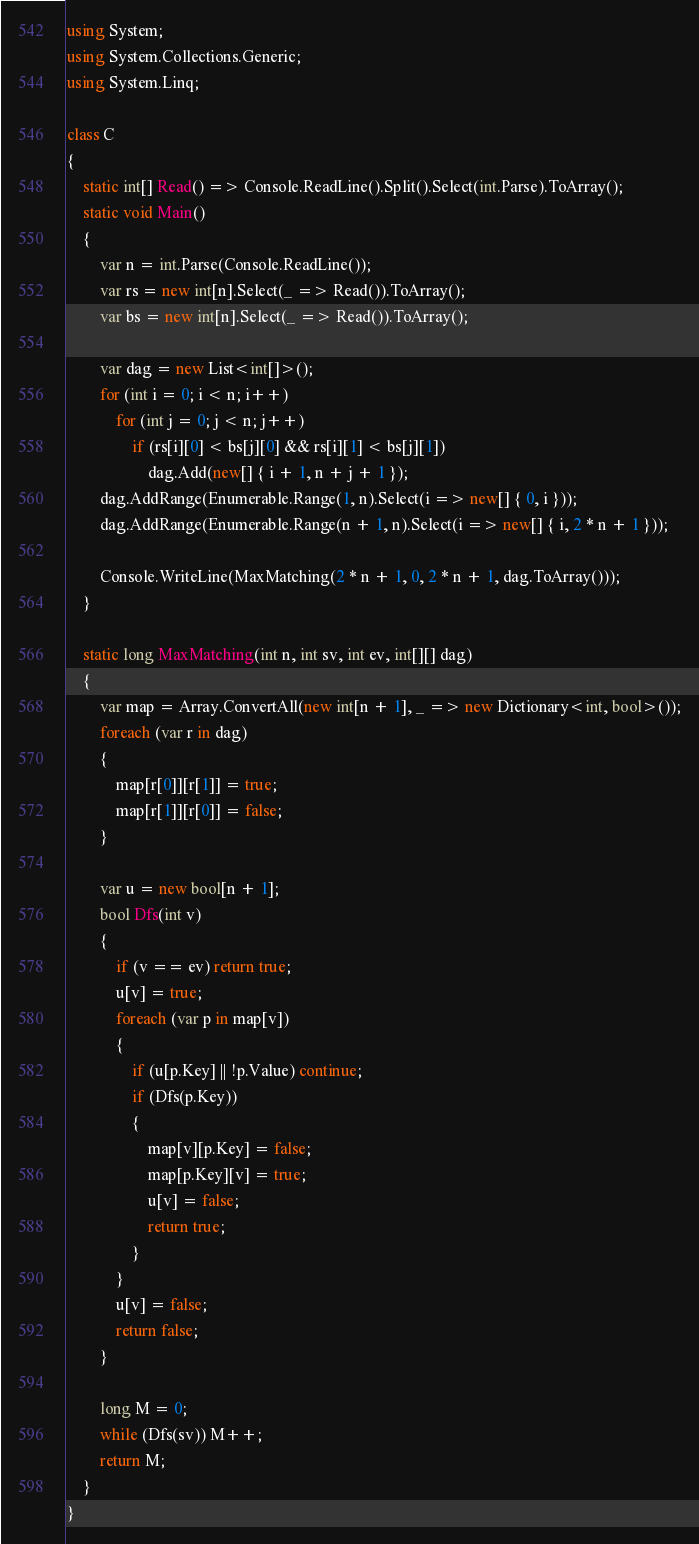<code> <loc_0><loc_0><loc_500><loc_500><_C#_>using System;
using System.Collections.Generic;
using System.Linq;

class C
{
	static int[] Read() => Console.ReadLine().Split().Select(int.Parse).ToArray();
	static void Main()
	{
		var n = int.Parse(Console.ReadLine());
		var rs = new int[n].Select(_ => Read()).ToArray();
		var bs = new int[n].Select(_ => Read()).ToArray();

		var dag = new List<int[]>();
		for (int i = 0; i < n; i++)
			for (int j = 0; j < n; j++)
				if (rs[i][0] < bs[j][0] && rs[i][1] < bs[j][1])
					dag.Add(new[] { i + 1, n + j + 1 });
		dag.AddRange(Enumerable.Range(1, n).Select(i => new[] { 0, i }));
		dag.AddRange(Enumerable.Range(n + 1, n).Select(i => new[] { i, 2 * n + 1 }));

		Console.WriteLine(MaxMatching(2 * n + 1, 0, 2 * n + 1, dag.ToArray()));
	}

	static long MaxMatching(int n, int sv, int ev, int[][] dag)
	{
		var map = Array.ConvertAll(new int[n + 1], _ => new Dictionary<int, bool>());
		foreach (var r in dag)
		{
			map[r[0]][r[1]] = true;
			map[r[1]][r[0]] = false;
		}

		var u = new bool[n + 1];
		bool Dfs(int v)
		{
			if (v == ev) return true;
			u[v] = true;
			foreach (var p in map[v])
			{
				if (u[p.Key] || !p.Value) continue;
				if (Dfs(p.Key))
				{
					map[v][p.Key] = false;
					map[p.Key][v] = true;
					u[v] = false;
					return true;
				}
			}
			u[v] = false;
			return false;
		}

		long M = 0;
		while (Dfs(sv)) M++;
		return M;
	}
}
</code> 